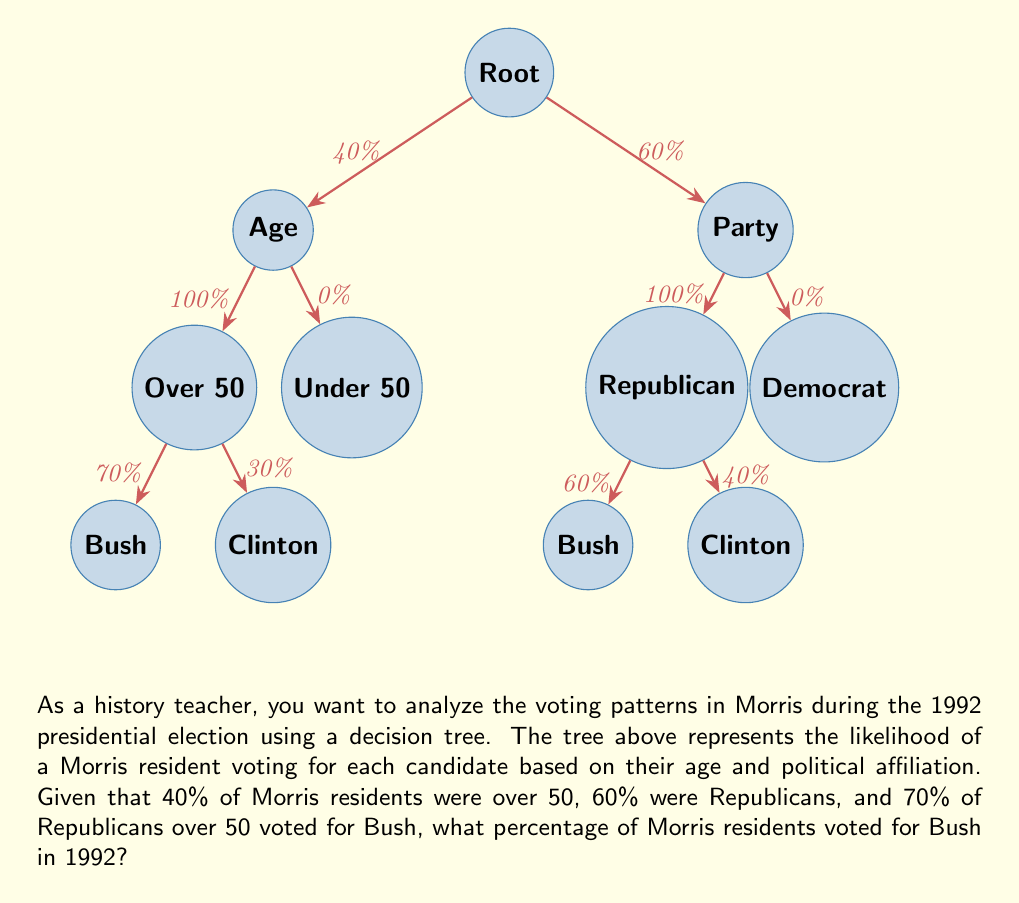Show me your answer to this math problem. Let's break this down step-by-step:

1) First, we need to identify the two paths that lead to voting for Bush:
   a) Over 50 AND Republican
   b) Under 50 AND Republican

2) Let's calculate the probability of each path:

   a) P(Over 50 AND Republican AND vote Bush) 
      = P(Over 50) × P(Republican) × P(Bush | Over 50 AND Republican)
      = 0.40 × 0.60 × 0.70 = 0.168 or 16.8%

   b) P(Under 50 AND Republican AND vote Bush)
      = P(Under 50) × P(Republican) × P(Bush | Under 50 AND Republican)
      = (1 - 0.40) × 0.60 × 0.60 = 0.216 or 21.6%

3) The total probability of voting for Bush is the sum of these two probabilities:

   P(Vote Bush) = P(Path a) + P(Path b)
                = 0.168 + 0.216 = 0.384

4) Convert to a percentage:
   0.384 × 100 = 38.4%

Therefore, 38.4% of Morris residents voted for Bush in the 1992 presidential election.
Answer: 38.4% 